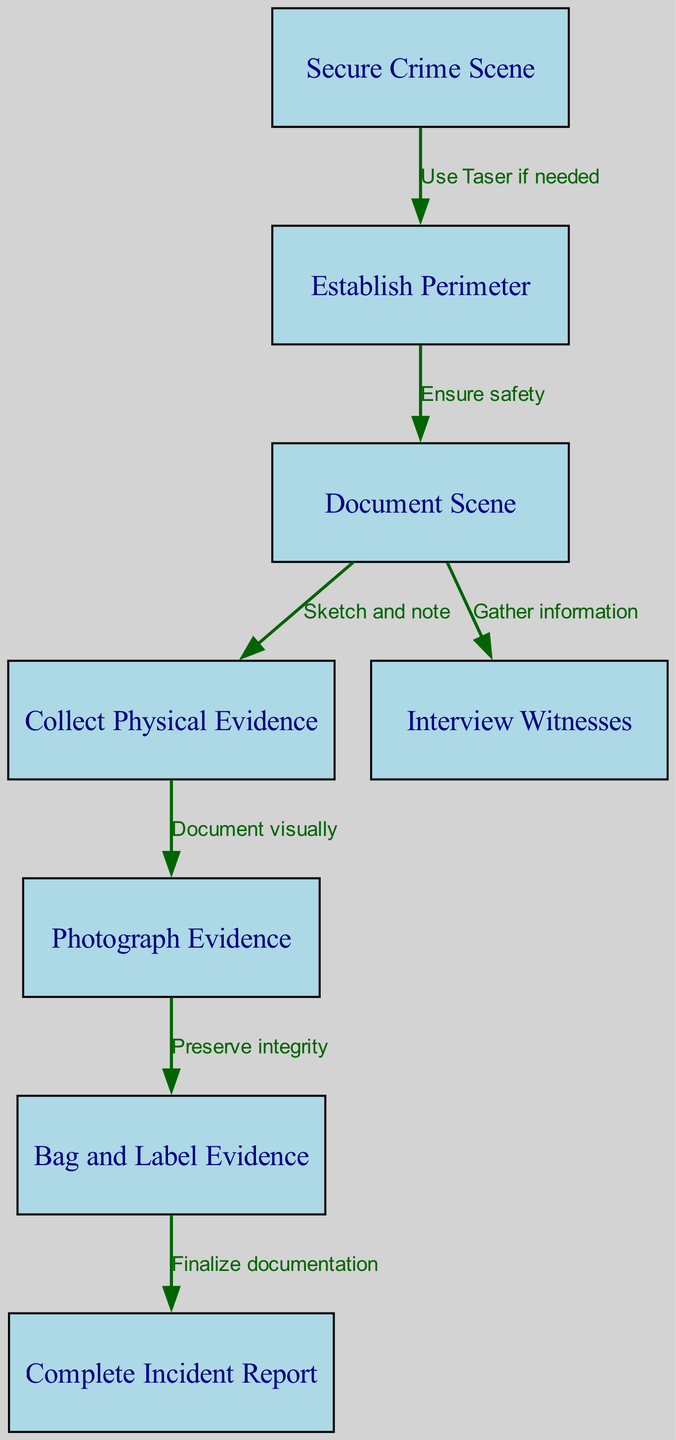What is the first step in the crime scene investigation procedure? The first step is "Secure Crime Scene," which is clearly shown as the initial node in the diagram.
Answer: Secure Crime Scene How many total nodes are present in the diagram? By counting each separate box labeled from "Secure Crime Scene" to "Complete Incident Report," we find there are 8 nodes in total.
Answer: 8 What action is indicated between securing the crime scene and establishing the perimeter? The diagram specifies "Use Taser if needed" as the required action moving from the "Secure Crime Scene" to "Establish Perimeter" nodes.
Answer: Use Taser if needed What is documented as evidence after collecting physical evidence? After collecting physical evidence, the diagram states that the next step is to "Photograph Evidence," which serves as documentation for the evidence collected.
Answer: Photograph Evidence What must be done to preserve the integrity of evidence after photographing it? The diagram indicates that the action between "Photograph Evidence" and "Bag and Label Evidence" is "Preserve integrity," which is crucial to maintaining the chain of custody.
Answer: Preserve integrity Which step follows the documentation of the scene? Following the "Document Scene," the next step outlined in the diagram is to "Collect Physical Evidence," indicating a direct flow from one to the other.
Answer: Collect Physical Evidence What is the final output of the crime scene investigation procedure according to the diagram? The final output, or last step shown in the diagram, is "Complete Incident Report," which summarizes all findings and actions taken during the investigation.
Answer: Complete Incident Report How does one gather information after documenting the scene? The diagram demonstrates that after documenting the scene, the step is to "Interview Witnesses," showing a clear flow from documentation to information gathering.
Answer: Interview Witnesses What guarantees safety before documenting the scene? According to the flow in the diagram, the action leading to "Document Scene" is "Ensure safety," ensuring that all personnel and bystanders are safe before proceeding.
Answer: Ensure safety 